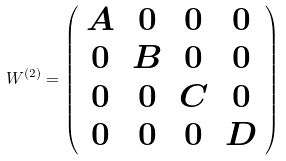Convert formula to latex. <formula><loc_0><loc_0><loc_500><loc_500>W ^ { ( 2 ) } = \left ( \begin{array} { c c c c } A & 0 & 0 & 0 \\ 0 & B & 0 & 0 \\ 0 & 0 & C & 0 \\ 0 & 0 & 0 & D \end{array} \right )</formula> 